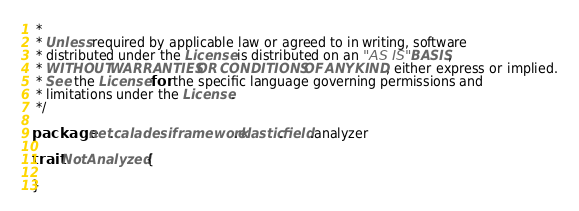<code> <loc_0><loc_0><loc_500><loc_500><_Scala_> *
 * Unless required by applicable law or agreed to in writing, software
 * distributed under the License is distributed on an "AS IS" BASIS,
 * WITHOUT WARRANTIES OR CONDITIONS OF ANY KIND, either express or implied.
 * See the License for the specific language governing permissions and
 * limitations under the License.
 */

package net.caladesiframework.elastic.field.analyzer

trait NotAnalyzed {

}
</code> 